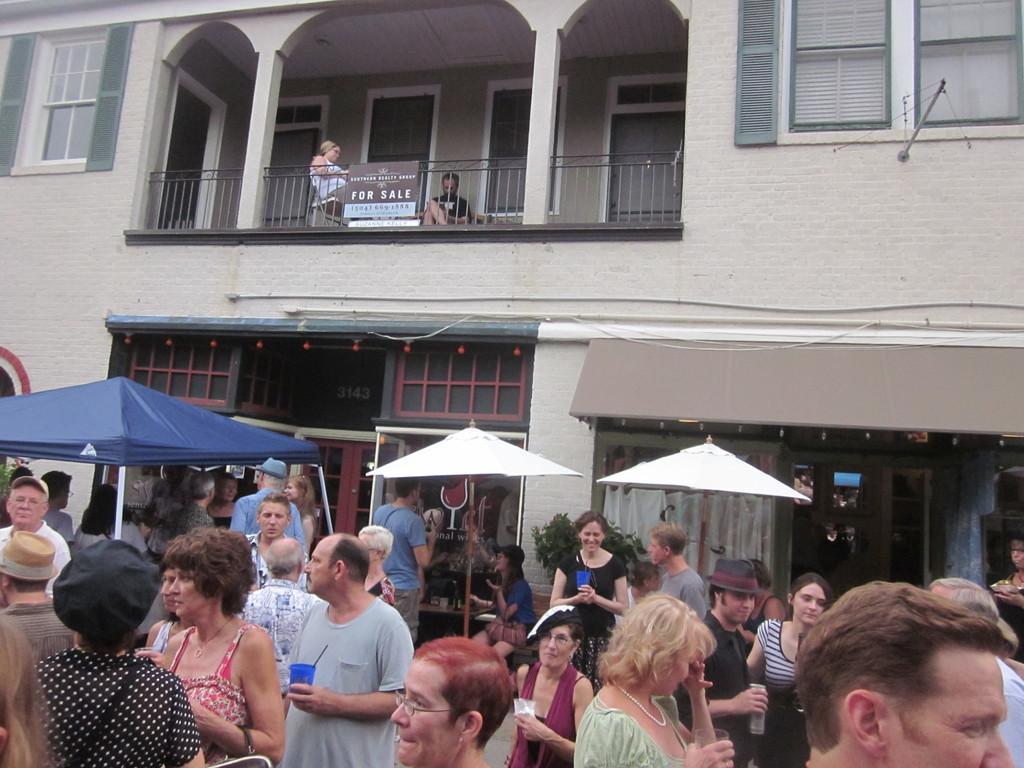What does the sign on the balcony say?
Provide a short and direct response. For sale. 